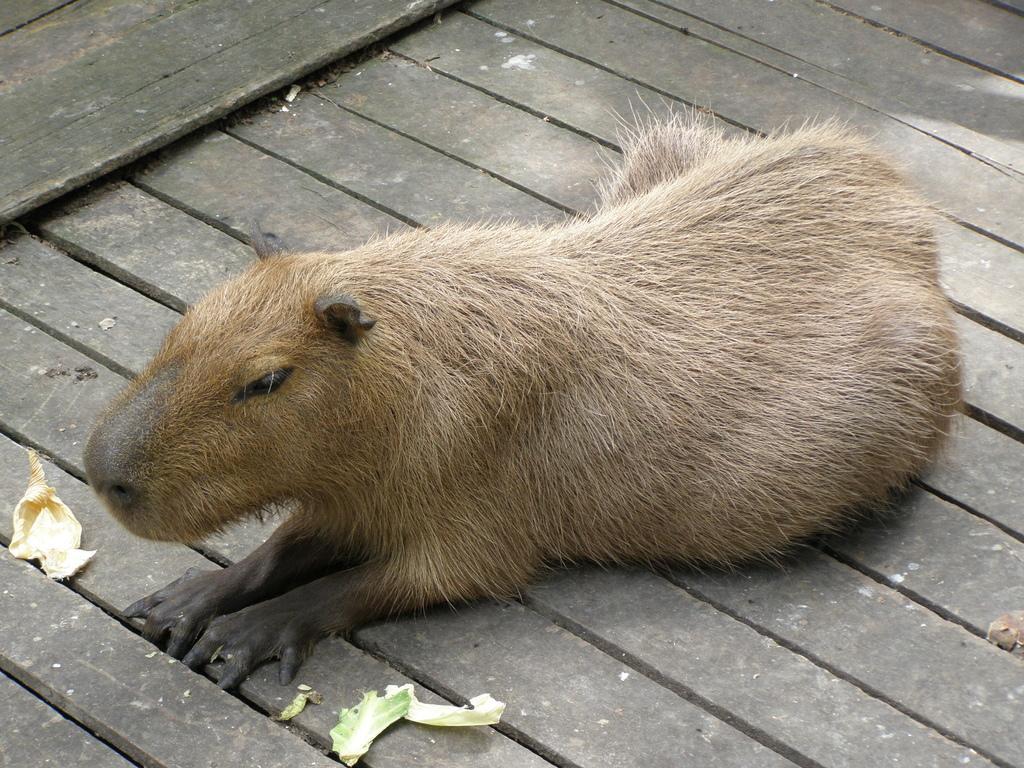Please provide a concise description of this image. In this image I can see a brown colour animal. I can also see few leaves over here. 